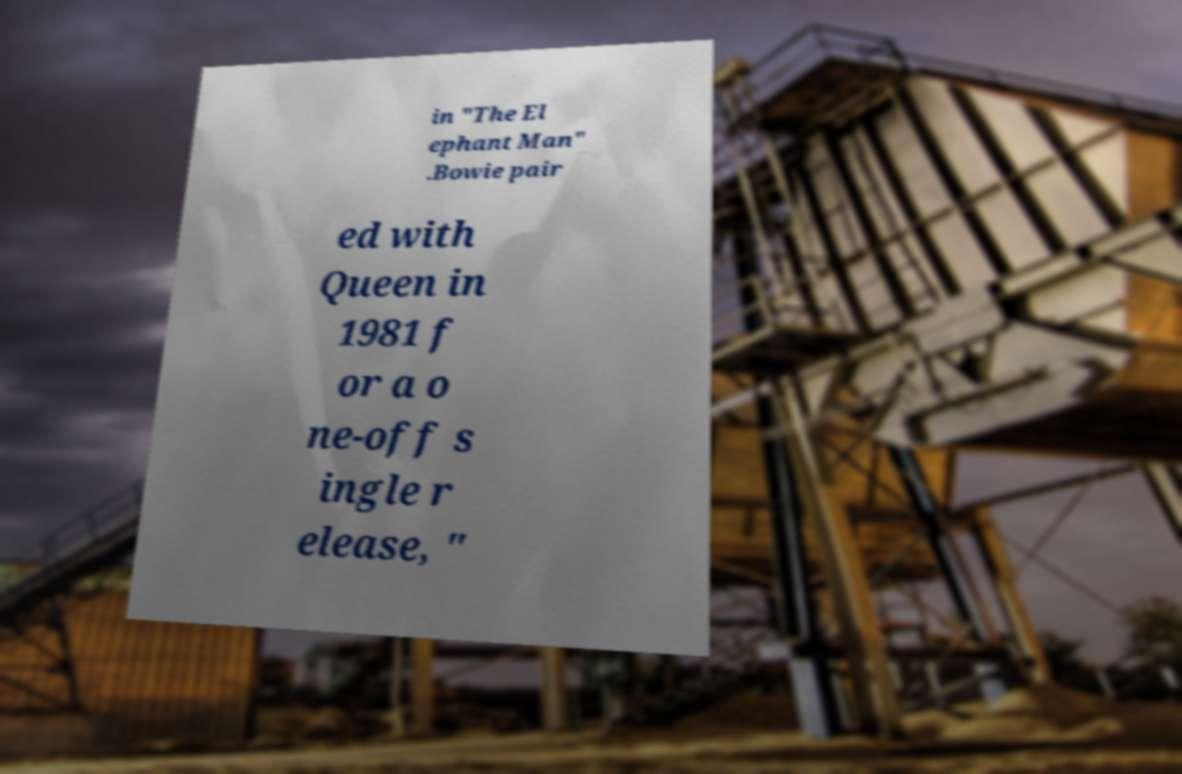Can you read and provide the text displayed in the image?This photo seems to have some interesting text. Can you extract and type it out for me? in "The El ephant Man" .Bowie pair ed with Queen in 1981 f or a o ne-off s ingle r elease, " 